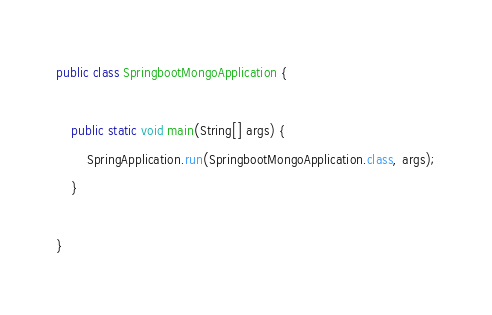Convert code to text. <code><loc_0><loc_0><loc_500><loc_500><_Java_>public class SpringbootMongoApplication {

	public static void main(String[] args) {
		SpringApplication.run(SpringbootMongoApplication.class, args);
	}

}
</code> 